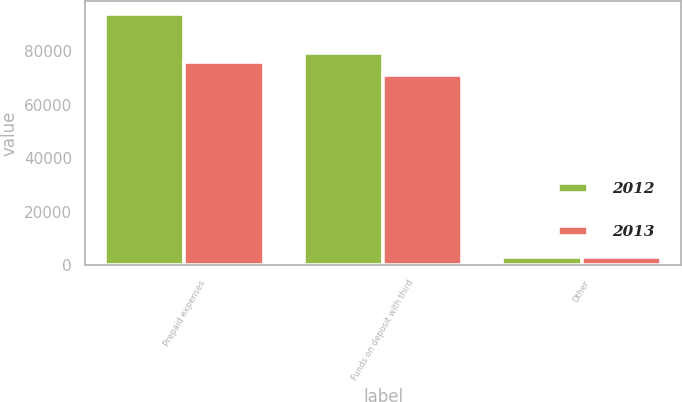Convert chart to OTSL. <chart><loc_0><loc_0><loc_500><loc_500><stacked_bar_chart><ecel><fcel>Prepaid expenses<fcel>Funds on deposit with third<fcel>Other<nl><fcel>2012<fcel>93877<fcel>79317<fcel>3220<nl><fcel>2013<fcel>75853<fcel>70922<fcel>3250<nl></chart> 